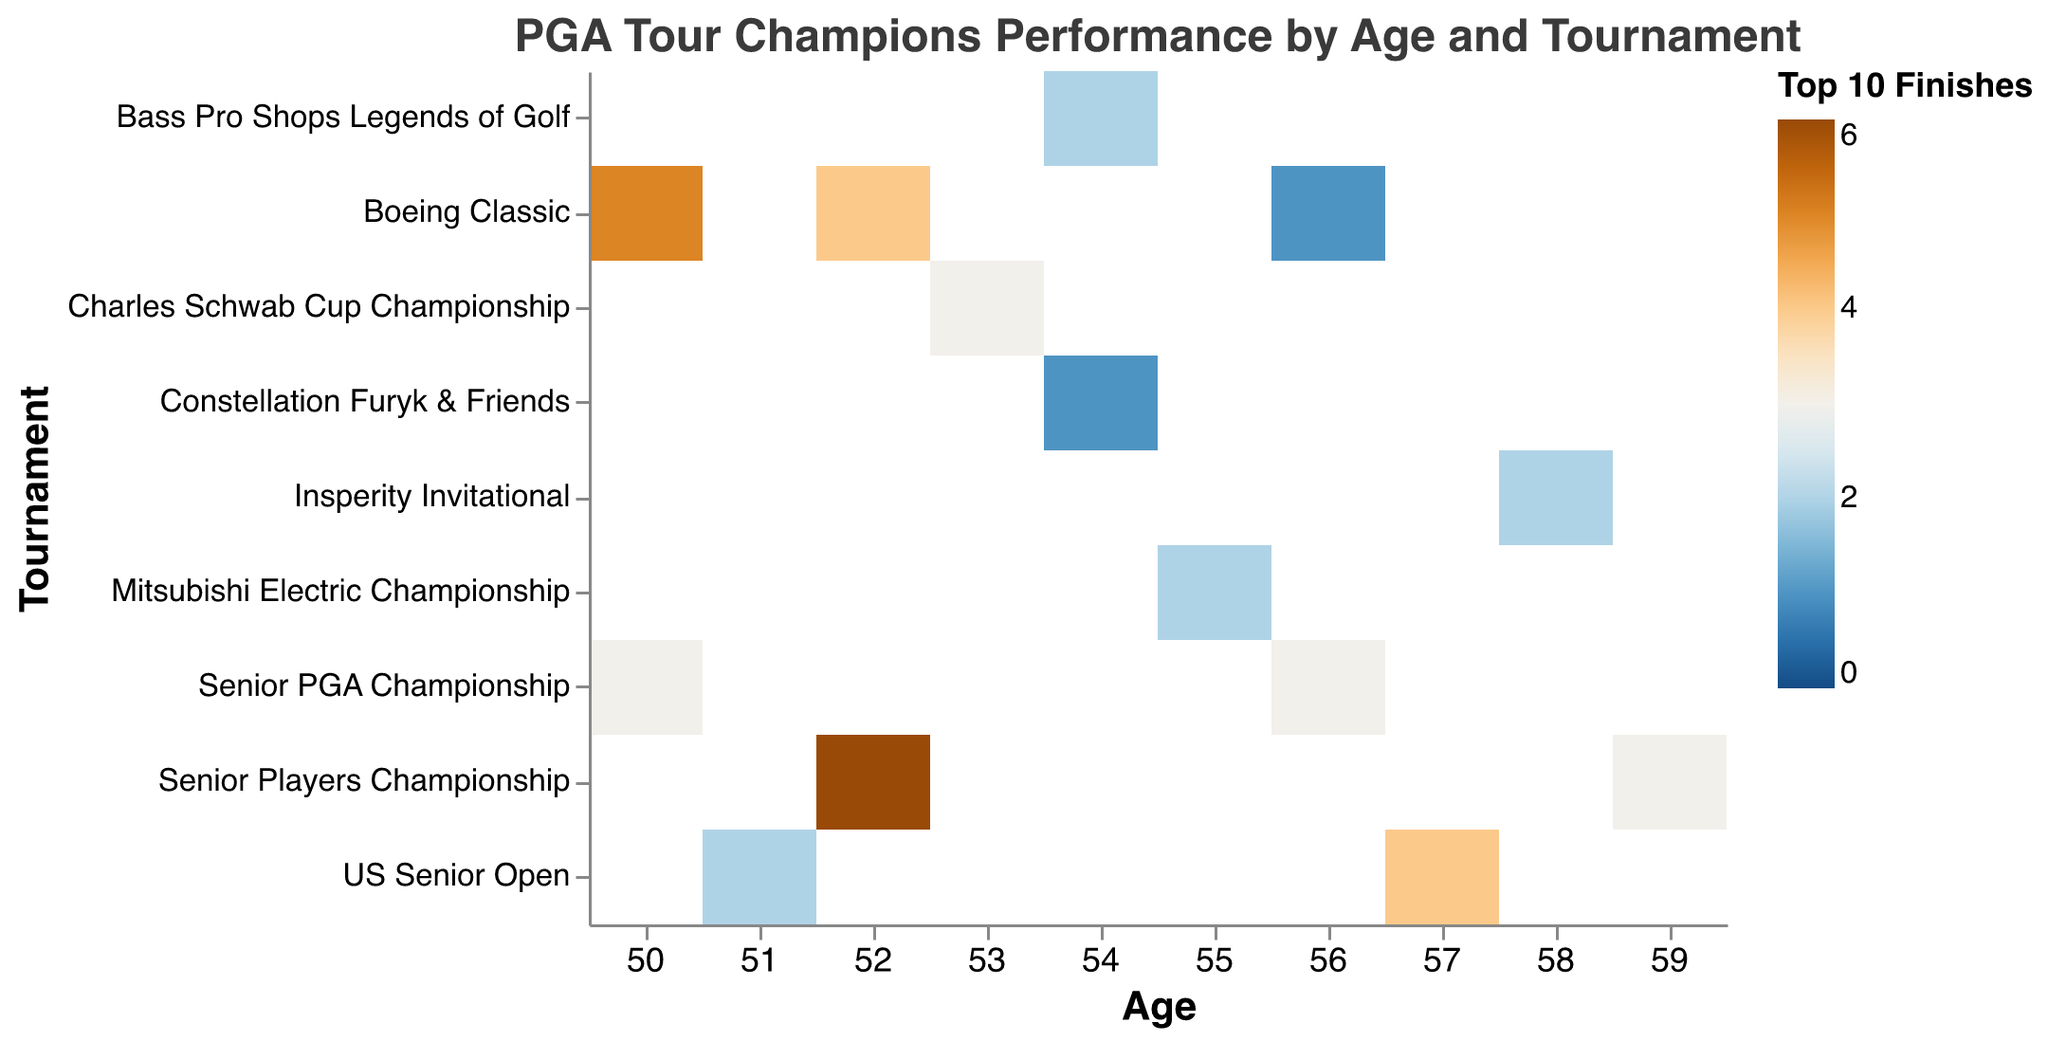What's the highest number of Top 10 Finishes recorded in the heatmap? To find this, look at the color legend correlated with "Top 10 Finishes" in the heatmap. The scale ranges from 0 to 6. Identify the darkest color in the plot, indicating the highest value for Top 10 Finishes.
Answer: 6 How many tournaments did players win at age 57? To answer this, locate the row corresponding to "Age: 57" and count instances where the "Wins" tooltip shows a value greater than 0. The heatmap color does not indicate wins directly, so use the tooltip data.
Answer: 2 Which tournament had the most Top 10 finishes by players aged 52? Identify the column for "Age: 52" and compare the color intensities (related to Top 10 Finishes) across all rows. The row with the darkest color indicates the highest number of Top 10 finishes.
Answer: Senior Players Championship What is the average number of Top 10 finishes for players aged 50? Add the Top 10 Finishes values for age 50, then divide by the number of tournaments at that age. Values are 5 (Boeing Classic) and 3 (Senior PGA Championship). So, (5+3)/2 = 4.
Answer: 4 Did any tournament see a win but fewer than three Top 10 finishes? For each cell, check if the "Wins" tooltip value is greater than 0 while the "Top 10 Finishes" value is less than 3. One such combination is aged 50 at "Senior PGA Championship" with 1 win and 3 Top 10 finishes and aged 54 at "Bass Pro Shops Legends of Golf" with 1 win and 2 Top 10 finishes. Aged 54 meets this condition
Answer: Yes Do players perform better at the Boeing Classic as they age? Compare Top 10 finishes for different ages at the Boeing Classic. Values: 5 (age 50), 4 (age 52), 1 (age 56). Observing these, performance declines with age.
Answer: No How many total wins are there for players aged 52 across all tournaments? Sum the wins for "Age: 52" across all tournaments. Values: 1 (Boeing Classic) and 2 (Senior Players Championship). The total is 1+2 = 3.
Answer: 3 